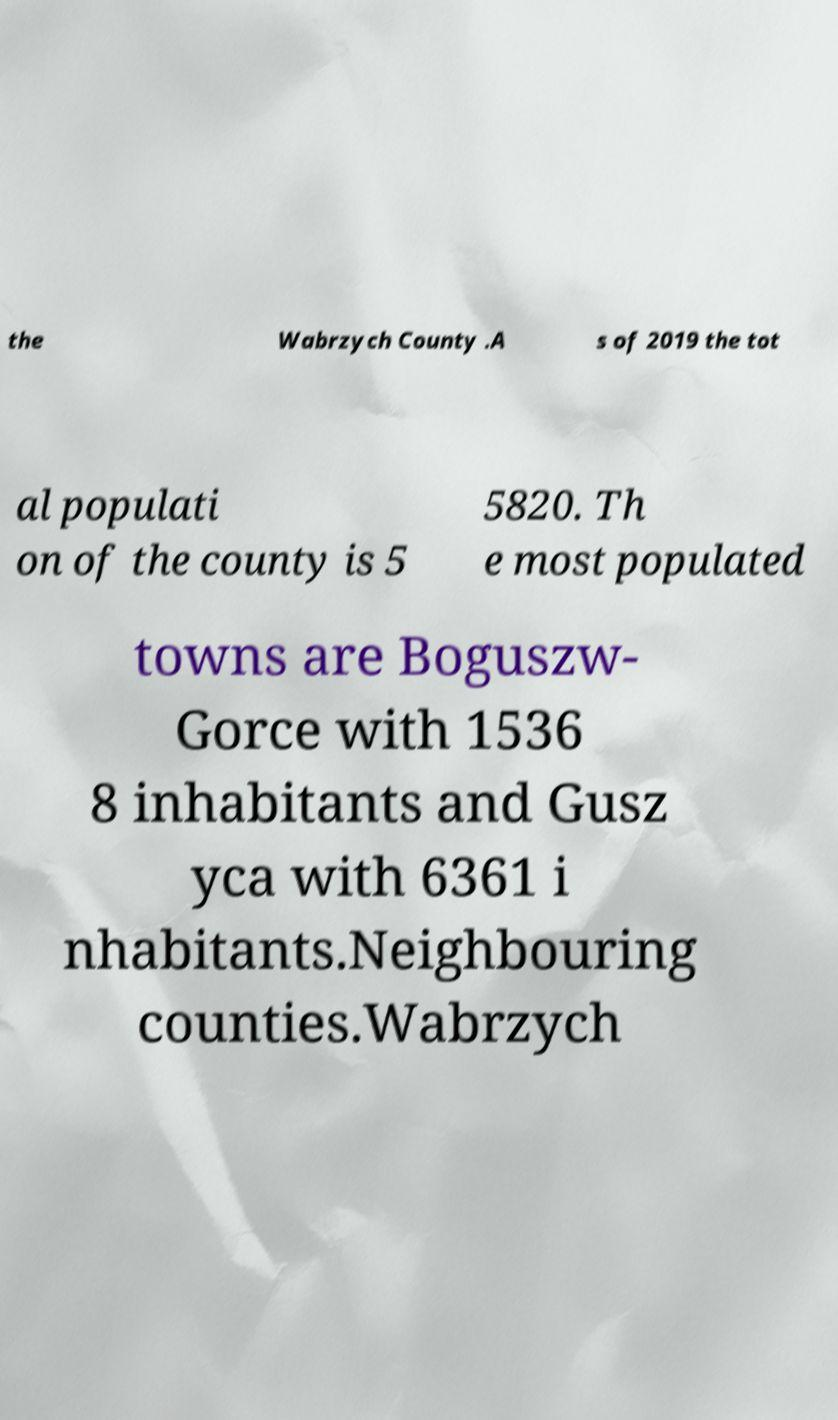There's text embedded in this image that I need extracted. Can you transcribe it verbatim? the Wabrzych County .A s of 2019 the tot al populati on of the county is 5 5820. Th e most populated towns are Boguszw- Gorce with 1536 8 inhabitants and Gusz yca with 6361 i nhabitants.Neighbouring counties.Wabrzych 